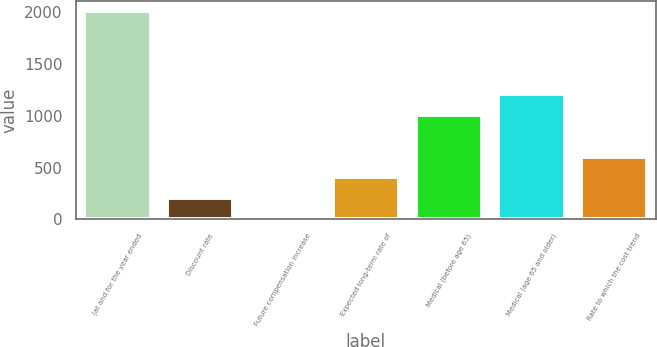Convert chart to OTSL. <chart><loc_0><loc_0><loc_500><loc_500><bar_chart><fcel>(at and for the year ended<fcel>Discount rate<fcel>Future compensation increase<fcel>Expected long-term rate of<fcel>Medical (before age 65)<fcel>Medical (age 65 and older)<fcel>Rate to which the cost trend<nl><fcel>2012<fcel>204.8<fcel>4<fcel>405.6<fcel>1008<fcel>1208.8<fcel>606.4<nl></chart> 